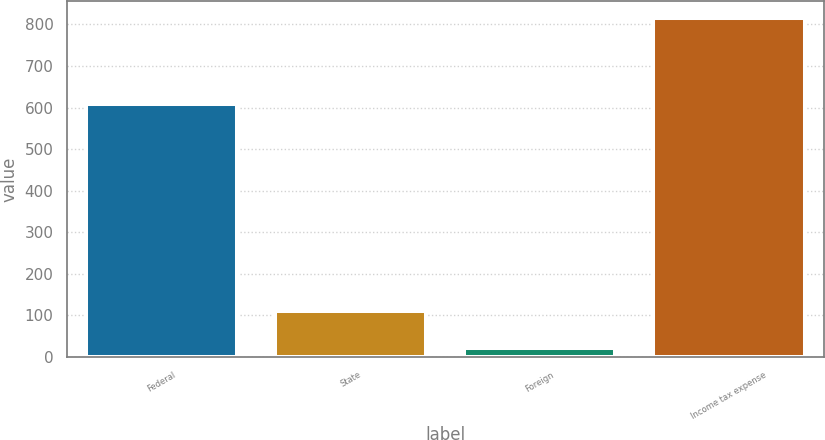Convert chart to OTSL. <chart><loc_0><loc_0><loc_500><loc_500><bar_chart><fcel>Federal<fcel>State<fcel>Foreign<fcel>Income tax expense<nl><fcel>609<fcel>110<fcel>22<fcel>815<nl></chart> 